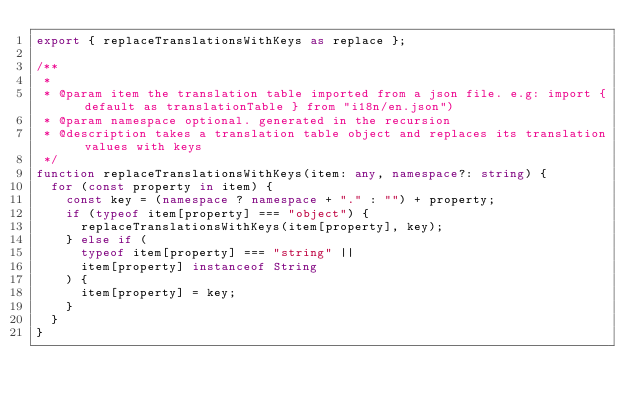<code> <loc_0><loc_0><loc_500><loc_500><_TypeScript_>export { replaceTranslationsWithKeys as replace };

/**
 *
 * @param item the translation table imported from a json file. e.g: import { default as translationTable } from "i18n/en.json")
 * @param namespace optional. generated in the recursion
 * @description takes a translation table object and replaces its translation values with keys
 */
function replaceTranslationsWithKeys(item: any, namespace?: string) {
  for (const property in item) {
    const key = (namespace ? namespace + "." : "") + property;
    if (typeof item[property] === "object") {
      replaceTranslationsWithKeys(item[property], key);
    } else if (
      typeof item[property] === "string" ||
      item[property] instanceof String
    ) {
      item[property] = key;
    }
  }
}
</code> 